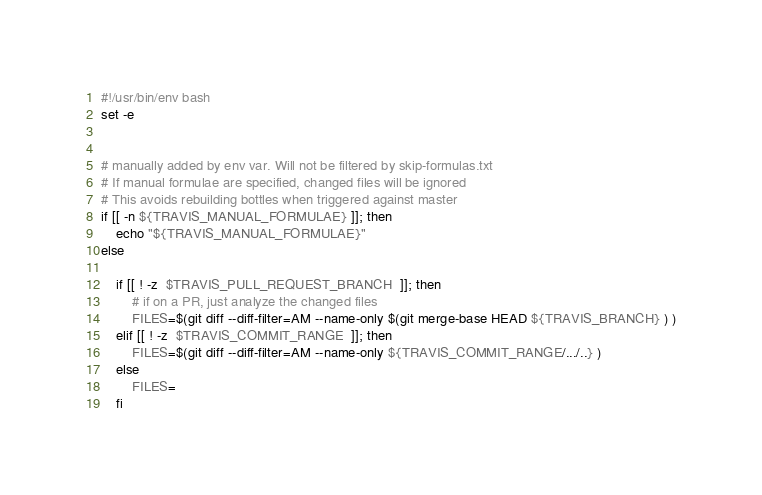<code> <loc_0><loc_0><loc_500><loc_500><_Bash_>#!/usr/bin/env bash
set -e


# manually added by env var. Will not be filtered by skip-formulas.txt
# If manual formulae are specified, changed files will be ignored
# This avoids rebuilding bottles when triggered against master
if [[ -n ${TRAVIS_MANUAL_FORMULAE} ]]; then
	echo "${TRAVIS_MANUAL_FORMULAE}"
else

	if [[ ! -z  $TRAVIS_PULL_REQUEST_BRANCH  ]]; then
		# if on a PR, just analyze the changed files
		FILES=$(git diff --diff-filter=AM --name-only $(git merge-base HEAD ${TRAVIS_BRANCH} ) )
	elif [[ ! -z  $TRAVIS_COMMIT_RANGE  ]]; then
		FILES=$(git diff --diff-filter=AM --name-only ${TRAVIS_COMMIT_RANGE/.../..} )
	else
		FILES=
	fi
</code> 